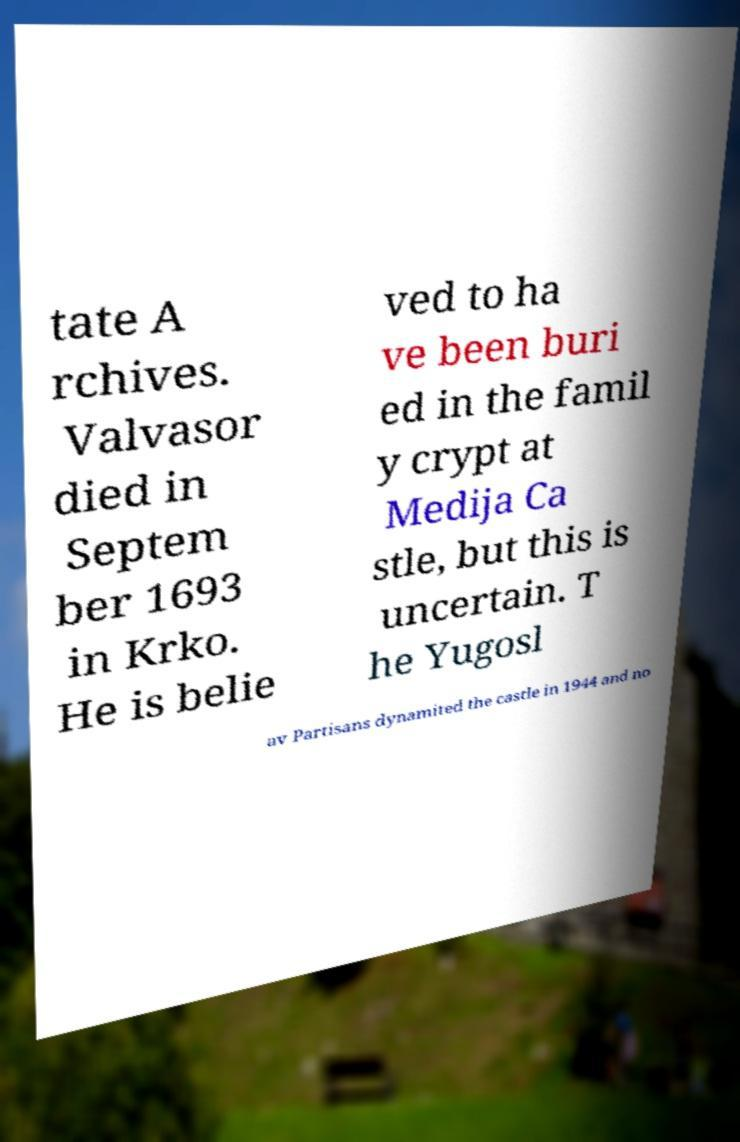Could you extract and type out the text from this image? tate A rchives. Valvasor died in Septem ber 1693 in Krko. He is belie ved to ha ve been buri ed in the famil y crypt at Medija Ca stle, but this is uncertain. T he Yugosl av Partisans dynamited the castle in 1944 and no 